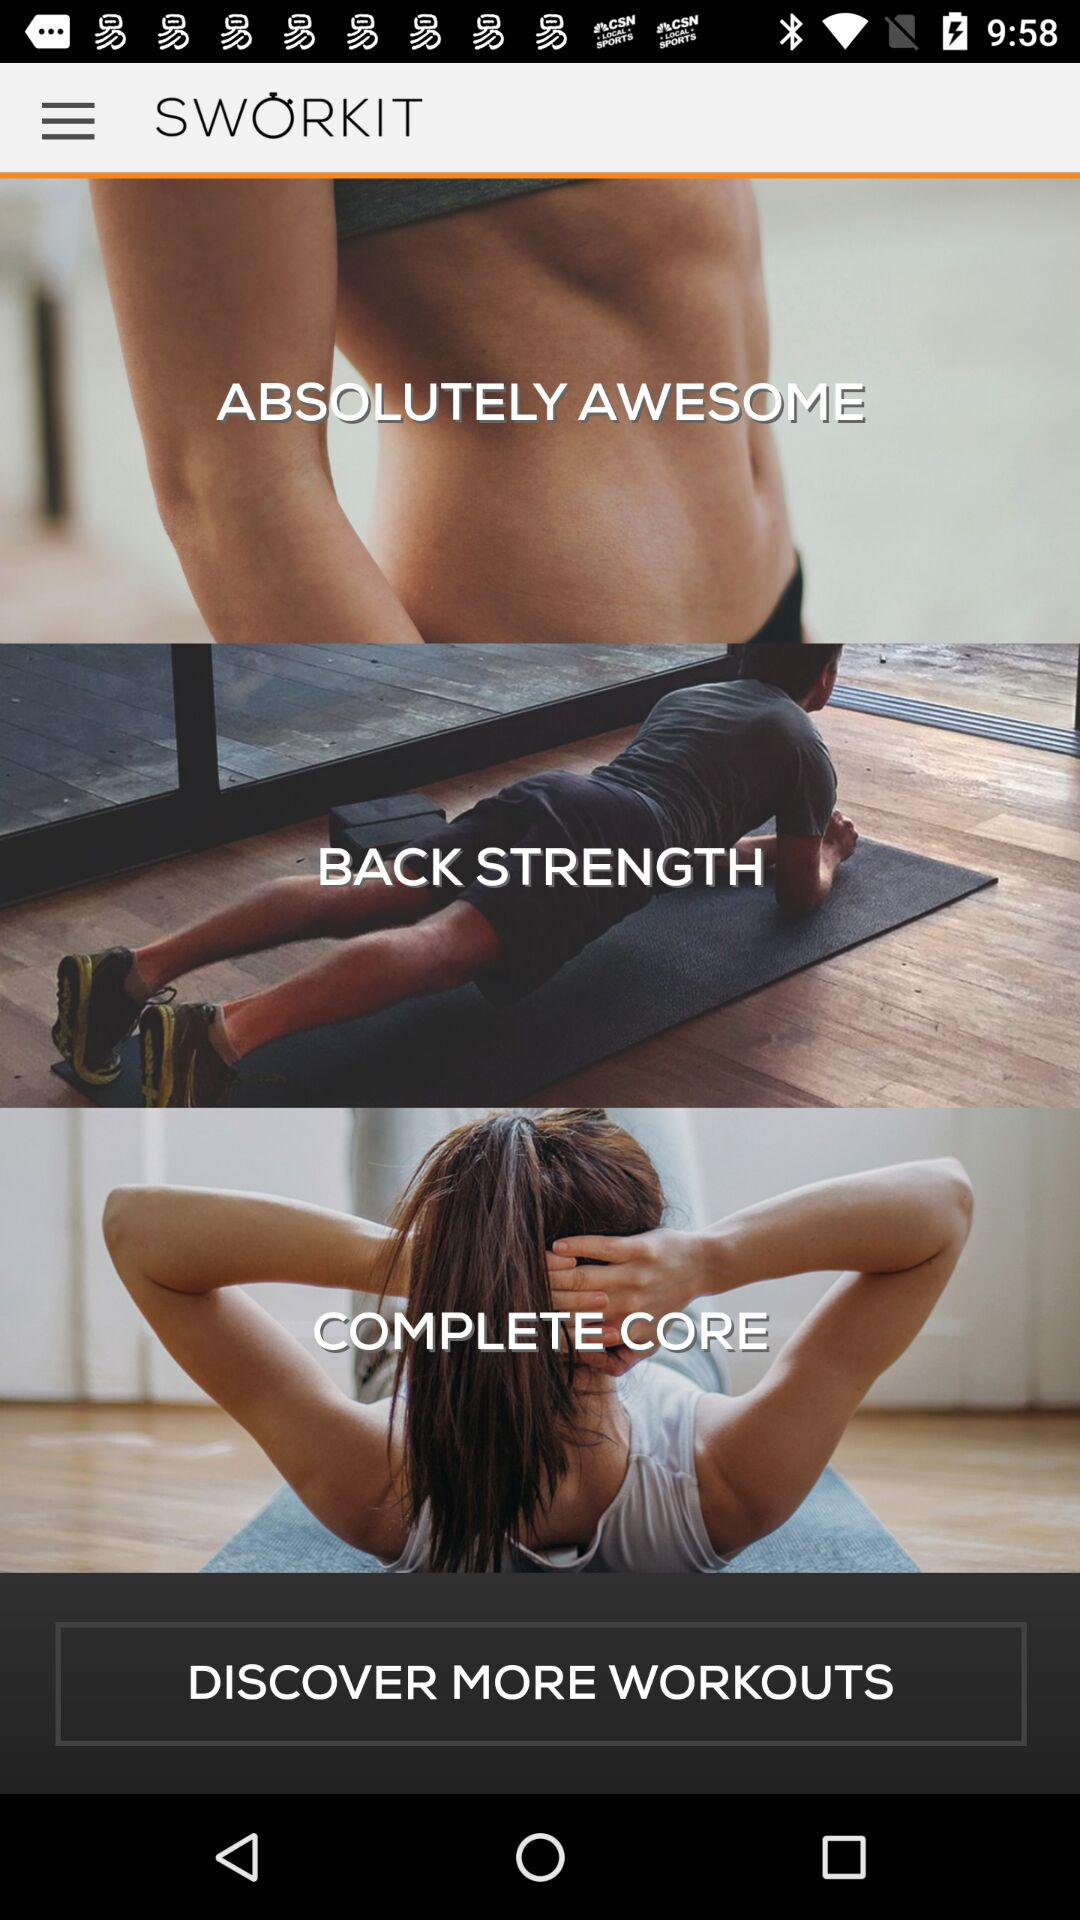How many workout categories are displayed?
Answer the question using a single word or phrase. 3 